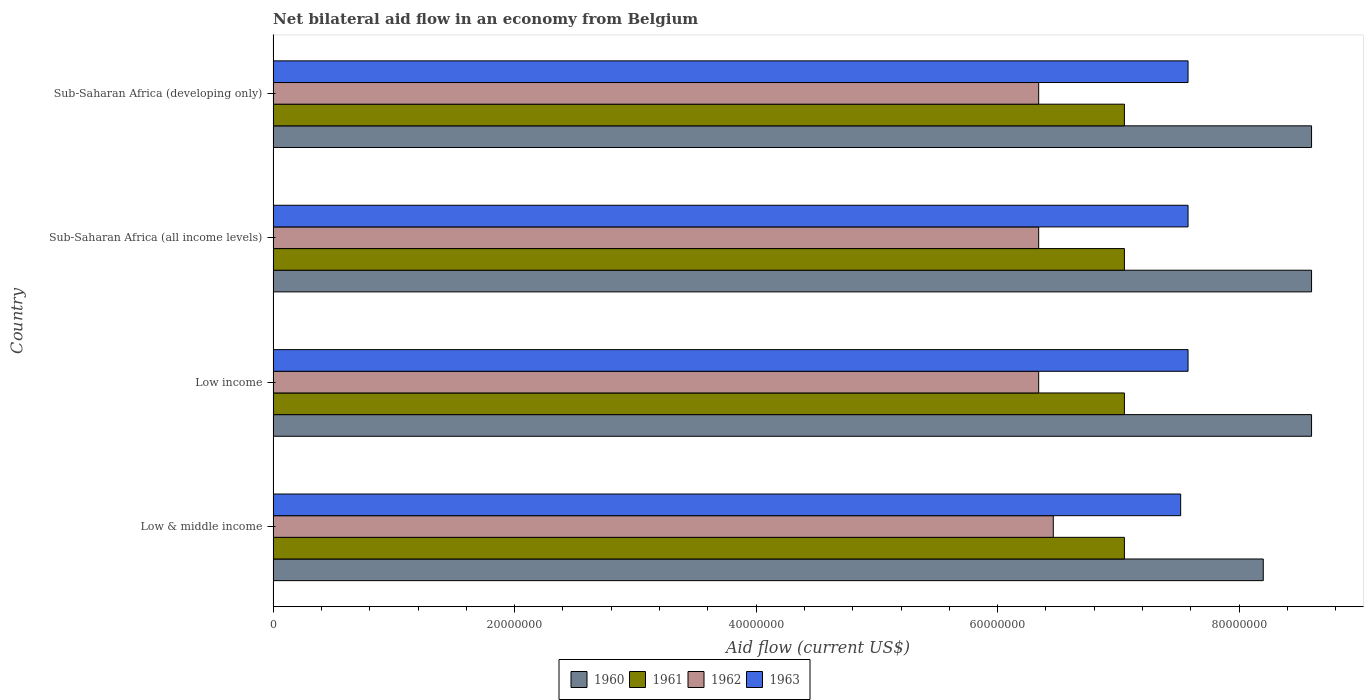How many different coloured bars are there?
Give a very brief answer. 4. Are the number of bars per tick equal to the number of legend labels?
Your answer should be compact. Yes. How many bars are there on the 1st tick from the top?
Your answer should be very brief. 4. What is the label of the 2nd group of bars from the top?
Ensure brevity in your answer.  Sub-Saharan Africa (all income levels). What is the net bilateral aid flow in 1961 in Sub-Saharan Africa (all income levels)?
Your response must be concise. 7.05e+07. Across all countries, what is the maximum net bilateral aid flow in 1962?
Your response must be concise. 6.46e+07. Across all countries, what is the minimum net bilateral aid flow in 1962?
Ensure brevity in your answer.  6.34e+07. What is the total net bilateral aid flow in 1962 in the graph?
Ensure brevity in your answer.  2.55e+08. What is the difference between the net bilateral aid flow in 1961 in Low income and that in Sub-Saharan Africa (all income levels)?
Provide a succinct answer. 0. What is the difference between the net bilateral aid flow in 1962 in Sub-Saharan Africa (all income levels) and the net bilateral aid flow in 1961 in Sub-Saharan Africa (developing only)?
Your response must be concise. -7.10e+06. What is the average net bilateral aid flow in 1962 per country?
Provide a succinct answer. 6.37e+07. What is the difference between the net bilateral aid flow in 1961 and net bilateral aid flow in 1960 in Low & middle income?
Provide a succinct answer. -1.15e+07. In how many countries, is the net bilateral aid flow in 1960 greater than 24000000 US$?
Keep it short and to the point. 4. What is the difference between the highest and the lowest net bilateral aid flow in 1962?
Provide a succinct answer. 1.21e+06. What does the 4th bar from the bottom in Sub-Saharan Africa (developing only) represents?
Your answer should be very brief. 1963. Are all the bars in the graph horizontal?
Keep it short and to the point. Yes. Are the values on the major ticks of X-axis written in scientific E-notation?
Give a very brief answer. No. Where does the legend appear in the graph?
Provide a succinct answer. Bottom center. What is the title of the graph?
Offer a very short reply. Net bilateral aid flow in an economy from Belgium. Does "1983" appear as one of the legend labels in the graph?
Your answer should be very brief. No. What is the label or title of the Y-axis?
Ensure brevity in your answer.  Country. What is the Aid flow (current US$) in 1960 in Low & middle income?
Ensure brevity in your answer.  8.20e+07. What is the Aid flow (current US$) in 1961 in Low & middle income?
Offer a very short reply. 7.05e+07. What is the Aid flow (current US$) in 1962 in Low & middle income?
Ensure brevity in your answer.  6.46e+07. What is the Aid flow (current US$) in 1963 in Low & middle income?
Provide a short and direct response. 7.52e+07. What is the Aid flow (current US$) of 1960 in Low income?
Ensure brevity in your answer.  8.60e+07. What is the Aid flow (current US$) in 1961 in Low income?
Your response must be concise. 7.05e+07. What is the Aid flow (current US$) of 1962 in Low income?
Offer a very short reply. 6.34e+07. What is the Aid flow (current US$) of 1963 in Low income?
Offer a very short reply. 7.58e+07. What is the Aid flow (current US$) of 1960 in Sub-Saharan Africa (all income levels)?
Your answer should be very brief. 8.60e+07. What is the Aid flow (current US$) in 1961 in Sub-Saharan Africa (all income levels)?
Your answer should be compact. 7.05e+07. What is the Aid flow (current US$) in 1962 in Sub-Saharan Africa (all income levels)?
Ensure brevity in your answer.  6.34e+07. What is the Aid flow (current US$) in 1963 in Sub-Saharan Africa (all income levels)?
Make the answer very short. 7.58e+07. What is the Aid flow (current US$) in 1960 in Sub-Saharan Africa (developing only)?
Ensure brevity in your answer.  8.60e+07. What is the Aid flow (current US$) in 1961 in Sub-Saharan Africa (developing only)?
Your answer should be very brief. 7.05e+07. What is the Aid flow (current US$) in 1962 in Sub-Saharan Africa (developing only)?
Your response must be concise. 6.34e+07. What is the Aid flow (current US$) in 1963 in Sub-Saharan Africa (developing only)?
Ensure brevity in your answer.  7.58e+07. Across all countries, what is the maximum Aid flow (current US$) of 1960?
Keep it short and to the point. 8.60e+07. Across all countries, what is the maximum Aid flow (current US$) in 1961?
Provide a short and direct response. 7.05e+07. Across all countries, what is the maximum Aid flow (current US$) in 1962?
Keep it short and to the point. 6.46e+07. Across all countries, what is the maximum Aid flow (current US$) of 1963?
Your answer should be very brief. 7.58e+07. Across all countries, what is the minimum Aid flow (current US$) in 1960?
Make the answer very short. 8.20e+07. Across all countries, what is the minimum Aid flow (current US$) in 1961?
Give a very brief answer. 7.05e+07. Across all countries, what is the minimum Aid flow (current US$) of 1962?
Your answer should be compact. 6.34e+07. Across all countries, what is the minimum Aid flow (current US$) of 1963?
Provide a succinct answer. 7.52e+07. What is the total Aid flow (current US$) of 1960 in the graph?
Keep it short and to the point. 3.40e+08. What is the total Aid flow (current US$) of 1961 in the graph?
Give a very brief answer. 2.82e+08. What is the total Aid flow (current US$) of 1962 in the graph?
Provide a short and direct response. 2.55e+08. What is the total Aid flow (current US$) of 1963 in the graph?
Provide a succinct answer. 3.02e+08. What is the difference between the Aid flow (current US$) in 1962 in Low & middle income and that in Low income?
Provide a succinct answer. 1.21e+06. What is the difference between the Aid flow (current US$) in 1963 in Low & middle income and that in Low income?
Give a very brief answer. -6.10e+05. What is the difference between the Aid flow (current US$) of 1960 in Low & middle income and that in Sub-Saharan Africa (all income levels)?
Make the answer very short. -4.00e+06. What is the difference between the Aid flow (current US$) in 1961 in Low & middle income and that in Sub-Saharan Africa (all income levels)?
Provide a succinct answer. 0. What is the difference between the Aid flow (current US$) in 1962 in Low & middle income and that in Sub-Saharan Africa (all income levels)?
Your answer should be very brief. 1.21e+06. What is the difference between the Aid flow (current US$) of 1963 in Low & middle income and that in Sub-Saharan Africa (all income levels)?
Ensure brevity in your answer.  -6.10e+05. What is the difference between the Aid flow (current US$) in 1962 in Low & middle income and that in Sub-Saharan Africa (developing only)?
Make the answer very short. 1.21e+06. What is the difference between the Aid flow (current US$) in 1963 in Low & middle income and that in Sub-Saharan Africa (developing only)?
Keep it short and to the point. -6.10e+05. What is the difference between the Aid flow (current US$) of 1960 in Low income and that in Sub-Saharan Africa (all income levels)?
Ensure brevity in your answer.  0. What is the difference between the Aid flow (current US$) of 1963 in Low income and that in Sub-Saharan Africa (all income levels)?
Ensure brevity in your answer.  0. What is the difference between the Aid flow (current US$) in 1962 in Low income and that in Sub-Saharan Africa (developing only)?
Offer a very short reply. 0. What is the difference between the Aid flow (current US$) in 1963 in Low income and that in Sub-Saharan Africa (developing only)?
Provide a succinct answer. 0. What is the difference between the Aid flow (current US$) of 1960 in Sub-Saharan Africa (all income levels) and that in Sub-Saharan Africa (developing only)?
Your response must be concise. 0. What is the difference between the Aid flow (current US$) of 1963 in Sub-Saharan Africa (all income levels) and that in Sub-Saharan Africa (developing only)?
Offer a terse response. 0. What is the difference between the Aid flow (current US$) of 1960 in Low & middle income and the Aid flow (current US$) of 1961 in Low income?
Provide a short and direct response. 1.15e+07. What is the difference between the Aid flow (current US$) of 1960 in Low & middle income and the Aid flow (current US$) of 1962 in Low income?
Offer a terse response. 1.86e+07. What is the difference between the Aid flow (current US$) in 1960 in Low & middle income and the Aid flow (current US$) in 1963 in Low income?
Keep it short and to the point. 6.23e+06. What is the difference between the Aid flow (current US$) of 1961 in Low & middle income and the Aid flow (current US$) of 1962 in Low income?
Ensure brevity in your answer.  7.10e+06. What is the difference between the Aid flow (current US$) of 1961 in Low & middle income and the Aid flow (current US$) of 1963 in Low income?
Provide a short and direct response. -5.27e+06. What is the difference between the Aid flow (current US$) of 1962 in Low & middle income and the Aid flow (current US$) of 1963 in Low income?
Offer a terse response. -1.12e+07. What is the difference between the Aid flow (current US$) in 1960 in Low & middle income and the Aid flow (current US$) in 1961 in Sub-Saharan Africa (all income levels)?
Your response must be concise. 1.15e+07. What is the difference between the Aid flow (current US$) of 1960 in Low & middle income and the Aid flow (current US$) of 1962 in Sub-Saharan Africa (all income levels)?
Keep it short and to the point. 1.86e+07. What is the difference between the Aid flow (current US$) in 1960 in Low & middle income and the Aid flow (current US$) in 1963 in Sub-Saharan Africa (all income levels)?
Offer a very short reply. 6.23e+06. What is the difference between the Aid flow (current US$) of 1961 in Low & middle income and the Aid flow (current US$) of 1962 in Sub-Saharan Africa (all income levels)?
Provide a short and direct response. 7.10e+06. What is the difference between the Aid flow (current US$) of 1961 in Low & middle income and the Aid flow (current US$) of 1963 in Sub-Saharan Africa (all income levels)?
Give a very brief answer. -5.27e+06. What is the difference between the Aid flow (current US$) of 1962 in Low & middle income and the Aid flow (current US$) of 1963 in Sub-Saharan Africa (all income levels)?
Keep it short and to the point. -1.12e+07. What is the difference between the Aid flow (current US$) of 1960 in Low & middle income and the Aid flow (current US$) of 1961 in Sub-Saharan Africa (developing only)?
Provide a succinct answer. 1.15e+07. What is the difference between the Aid flow (current US$) of 1960 in Low & middle income and the Aid flow (current US$) of 1962 in Sub-Saharan Africa (developing only)?
Keep it short and to the point. 1.86e+07. What is the difference between the Aid flow (current US$) in 1960 in Low & middle income and the Aid flow (current US$) in 1963 in Sub-Saharan Africa (developing only)?
Make the answer very short. 6.23e+06. What is the difference between the Aid flow (current US$) in 1961 in Low & middle income and the Aid flow (current US$) in 1962 in Sub-Saharan Africa (developing only)?
Your answer should be very brief. 7.10e+06. What is the difference between the Aid flow (current US$) of 1961 in Low & middle income and the Aid flow (current US$) of 1963 in Sub-Saharan Africa (developing only)?
Give a very brief answer. -5.27e+06. What is the difference between the Aid flow (current US$) in 1962 in Low & middle income and the Aid flow (current US$) in 1963 in Sub-Saharan Africa (developing only)?
Ensure brevity in your answer.  -1.12e+07. What is the difference between the Aid flow (current US$) in 1960 in Low income and the Aid flow (current US$) in 1961 in Sub-Saharan Africa (all income levels)?
Offer a very short reply. 1.55e+07. What is the difference between the Aid flow (current US$) in 1960 in Low income and the Aid flow (current US$) in 1962 in Sub-Saharan Africa (all income levels)?
Provide a succinct answer. 2.26e+07. What is the difference between the Aid flow (current US$) of 1960 in Low income and the Aid flow (current US$) of 1963 in Sub-Saharan Africa (all income levels)?
Offer a very short reply. 1.02e+07. What is the difference between the Aid flow (current US$) in 1961 in Low income and the Aid flow (current US$) in 1962 in Sub-Saharan Africa (all income levels)?
Offer a very short reply. 7.10e+06. What is the difference between the Aid flow (current US$) of 1961 in Low income and the Aid flow (current US$) of 1963 in Sub-Saharan Africa (all income levels)?
Give a very brief answer. -5.27e+06. What is the difference between the Aid flow (current US$) of 1962 in Low income and the Aid flow (current US$) of 1963 in Sub-Saharan Africa (all income levels)?
Give a very brief answer. -1.24e+07. What is the difference between the Aid flow (current US$) of 1960 in Low income and the Aid flow (current US$) of 1961 in Sub-Saharan Africa (developing only)?
Give a very brief answer. 1.55e+07. What is the difference between the Aid flow (current US$) of 1960 in Low income and the Aid flow (current US$) of 1962 in Sub-Saharan Africa (developing only)?
Offer a terse response. 2.26e+07. What is the difference between the Aid flow (current US$) in 1960 in Low income and the Aid flow (current US$) in 1963 in Sub-Saharan Africa (developing only)?
Your answer should be compact. 1.02e+07. What is the difference between the Aid flow (current US$) in 1961 in Low income and the Aid flow (current US$) in 1962 in Sub-Saharan Africa (developing only)?
Make the answer very short. 7.10e+06. What is the difference between the Aid flow (current US$) in 1961 in Low income and the Aid flow (current US$) in 1963 in Sub-Saharan Africa (developing only)?
Make the answer very short. -5.27e+06. What is the difference between the Aid flow (current US$) in 1962 in Low income and the Aid flow (current US$) in 1963 in Sub-Saharan Africa (developing only)?
Provide a succinct answer. -1.24e+07. What is the difference between the Aid flow (current US$) of 1960 in Sub-Saharan Africa (all income levels) and the Aid flow (current US$) of 1961 in Sub-Saharan Africa (developing only)?
Provide a short and direct response. 1.55e+07. What is the difference between the Aid flow (current US$) of 1960 in Sub-Saharan Africa (all income levels) and the Aid flow (current US$) of 1962 in Sub-Saharan Africa (developing only)?
Ensure brevity in your answer.  2.26e+07. What is the difference between the Aid flow (current US$) of 1960 in Sub-Saharan Africa (all income levels) and the Aid flow (current US$) of 1963 in Sub-Saharan Africa (developing only)?
Give a very brief answer. 1.02e+07. What is the difference between the Aid flow (current US$) of 1961 in Sub-Saharan Africa (all income levels) and the Aid flow (current US$) of 1962 in Sub-Saharan Africa (developing only)?
Provide a short and direct response. 7.10e+06. What is the difference between the Aid flow (current US$) in 1961 in Sub-Saharan Africa (all income levels) and the Aid flow (current US$) in 1963 in Sub-Saharan Africa (developing only)?
Offer a very short reply. -5.27e+06. What is the difference between the Aid flow (current US$) of 1962 in Sub-Saharan Africa (all income levels) and the Aid flow (current US$) of 1963 in Sub-Saharan Africa (developing only)?
Offer a very short reply. -1.24e+07. What is the average Aid flow (current US$) of 1960 per country?
Give a very brief answer. 8.50e+07. What is the average Aid flow (current US$) of 1961 per country?
Keep it short and to the point. 7.05e+07. What is the average Aid flow (current US$) of 1962 per country?
Offer a very short reply. 6.37e+07. What is the average Aid flow (current US$) of 1963 per country?
Provide a succinct answer. 7.56e+07. What is the difference between the Aid flow (current US$) of 1960 and Aid flow (current US$) of 1961 in Low & middle income?
Offer a very short reply. 1.15e+07. What is the difference between the Aid flow (current US$) of 1960 and Aid flow (current US$) of 1962 in Low & middle income?
Offer a terse response. 1.74e+07. What is the difference between the Aid flow (current US$) of 1960 and Aid flow (current US$) of 1963 in Low & middle income?
Offer a terse response. 6.84e+06. What is the difference between the Aid flow (current US$) of 1961 and Aid flow (current US$) of 1962 in Low & middle income?
Your response must be concise. 5.89e+06. What is the difference between the Aid flow (current US$) of 1961 and Aid flow (current US$) of 1963 in Low & middle income?
Keep it short and to the point. -4.66e+06. What is the difference between the Aid flow (current US$) of 1962 and Aid flow (current US$) of 1963 in Low & middle income?
Keep it short and to the point. -1.06e+07. What is the difference between the Aid flow (current US$) of 1960 and Aid flow (current US$) of 1961 in Low income?
Provide a succinct answer. 1.55e+07. What is the difference between the Aid flow (current US$) in 1960 and Aid flow (current US$) in 1962 in Low income?
Offer a very short reply. 2.26e+07. What is the difference between the Aid flow (current US$) of 1960 and Aid flow (current US$) of 1963 in Low income?
Provide a succinct answer. 1.02e+07. What is the difference between the Aid flow (current US$) of 1961 and Aid flow (current US$) of 1962 in Low income?
Provide a short and direct response. 7.10e+06. What is the difference between the Aid flow (current US$) of 1961 and Aid flow (current US$) of 1963 in Low income?
Your answer should be compact. -5.27e+06. What is the difference between the Aid flow (current US$) in 1962 and Aid flow (current US$) in 1963 in Low income?
Your response must be concise. -1.24e+07. What is the difference between the Aid flow (current US$) in 1960 and Aid flow (current US$) in 1961 in Sub-Saharan Africa (all income levels)?
Offer a terse response. 1.55e+07. What is the difference between the Aid flow (current US$) in 1960 and Aid flow (current US$) in 1962 in Sub-Saharan Africa (all income levels)?
Give a very brief answer. 2.26e+07. What is the difference between the Aid flow (current US$) of 1960 and Aid flow (current US$) of 1963 in Sub-Saharan Africa (all income levels)?
Offer a terse response. 1.02e+07. What is the difference between the Aid flow (current US$) in 1961 and Aid flow (current US$) in 1962 in Sub-Saharan Africa (all income levels)?
Offer a very short reply. 7.10e+06. What is the difference between the Aid flow (current US$) of 1961 and Aid flow (current US$) of 1963 in Sub-Saharan Africa (all income levels)?
Offer a terse response. -5.27e+06. What is the difference between the Aid flow (current US$) of 1962 and Aid flow (current US$) of 1963 in Sub-Saharan Africa (all income levels)?
Offer a terse response. -1.24e+07. What is the difference between the Aid flow (current US$) of 1960 and Aid flow (current US$) of 1961 in Sub-Saharan Africa (developing only)?
Offer a very short reply. 1.55e+07. What is the difference between the Aid flow (current US$) in 1960 and Aid flow (current US$) in 1962 in Sub-Saharan Africa (developing only)?
Give a very brief answer. 2.26e+07. What is the difference between the Aid flow (current US$) in 1960 and Aid flow (current US$) in 1963 in Sub-Saharan Africa (developing only)?
Give a very brief answer. 1.02e+07. What is the difference between the Aid flow (current US$) in 1961 and Aid flow (current US$) in 1962 in Sub-Saharan Africa (developing only)?
Provide a short and direct response. 7.10e+06. What is the difference between the Aid flow (current US$) of 1961 and Aid flow (current US$) of 1963 in Sub-Saharan Africa (developing only)?
Your answer should be very brief. -5.27e+06. What is the difference between the Aid flow (current US$) in 1962 and Aid flow (current US$) in 1963 in Sub-Saharan Africa (developing only)?
Your response must be concise. -1.24e+07. What is the ratio of the Aid flow (current US$) of 1960 in Low & middle income to that in Low income?
Ensure brevity in your answer.  0.95. What is the ratio of the Aid flow (current US$) of 1961 in Low & middle income to that in Low income?
Your response must be concise. 1. What is the ratio of the Aid flow (current US$) of 1962 in Low & middle income to that in Low income?
Give a very brief answer. 1.02. What is the ratio of the Aid flow (current US$) in 1960 in Low & middle income to that in Sub-Saharan Africa (all income levels)?
Ensure brevity in your answer.  0.95. What is the ratio of the Aid flow (current US$) of 1961 in Low & middle income to that in Sub-Saharan Africa (all income levels)?
Your response must be concise. 1. What is the ratio of the Aid flow (current US$) of 1962 in Low & middle income to that in Sub-Saharan Africa (all income levels)?
Give a very brief answer. 1.02. What is the ratio of the Aid flow (current US$) of 1960 in Low & middle income to that in Sub-Saharan Africa (developing only)?
Your response must be concise. 0.95. What is the ratio of the Aid flow (current US$) of 1961 in Low & middle income to that in Sub-Saharan Africa (developing only)?
Offer a terse response. 1. What is the ratio of the Aid flow (current US$) of 1962 in Low & middle income to that in Sub-Saharan Africa (developing only)?
Provide a short and direct response. 1.02. What is the ratio of the Aid flow (current US$) in 1961 in Low income to that in Sub-Saharan Africa (all income levels)?
Keep it short and to the point. 1. What is the ratio of the Aid flow (current US$) of 1962 in Low income to that in Sub-Saharan Africa (all income levels)?
Provide a succinct answer. 1. What is the ratio of the Aid flow (current US$) in 1961 in Low income to that in Sub-Saharan Africa (developing only)?
Offer a terse response. 1. What is the ratio of the Aid flow (current US$) of 1962 in Low income to that in Sub-Saharan Africa (developing only)?
Provide a succinct answer. 1. What is the ratio of the Aid flow (current US$) of 1960 in Sub-Saharan Africa (all income levels) to that in Sub-Saharan Africa (developing only)?
Keep it short and to the point. 1. What is the difference between the highest and the second highest Aid flow (current US$) in 1961?
Give a very brief answer. 0. What is the difference between the highest and the second highest Aid flow (current US$) of 1962?
Your answer should be very brief. 1.21e+06. What is the difference between the highest and the lowest Aid flow (current US$) of 1962?
Your answer should be very brief. 1.21e+06. What is the difference between the highest and the lowest Aid flow (current US$) in 1963?
Provide a succinct answer. 6.10e+05. 